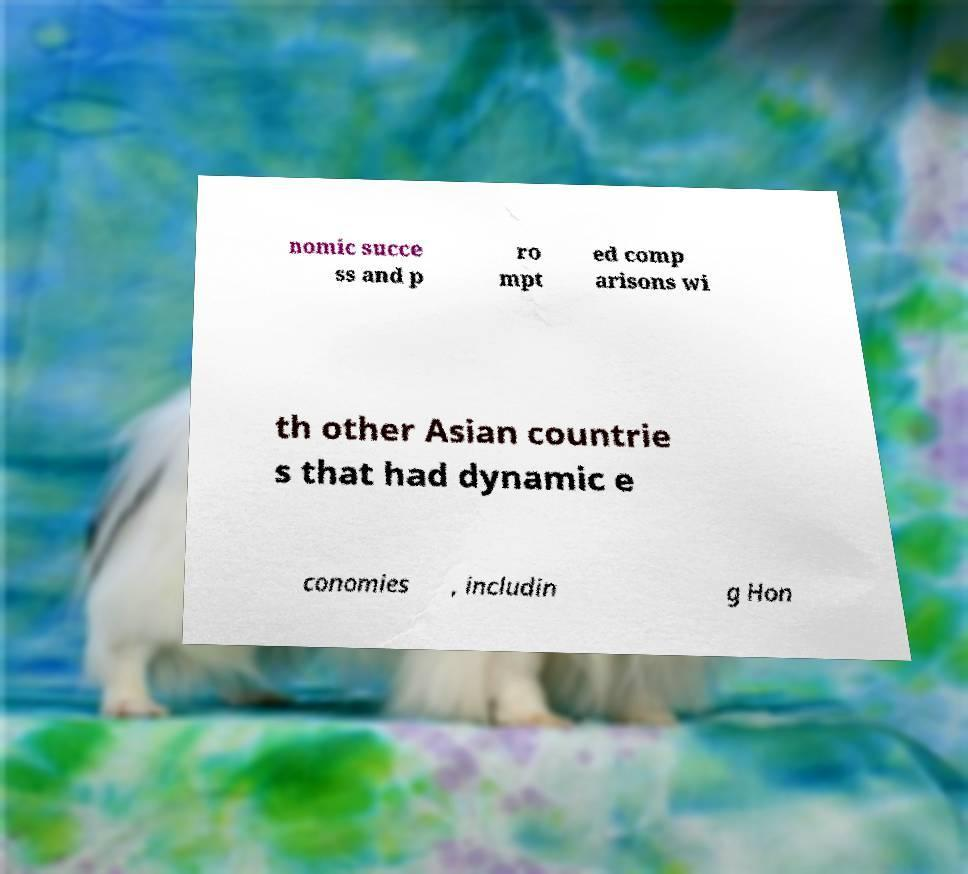For documentation purposes, I need the text within this image transcribed. Could you provide that? nomic succe ss and p ro mpt ed comp arisons wi th other Asian countrie s that had dynamic e conomies , includin g Hon 